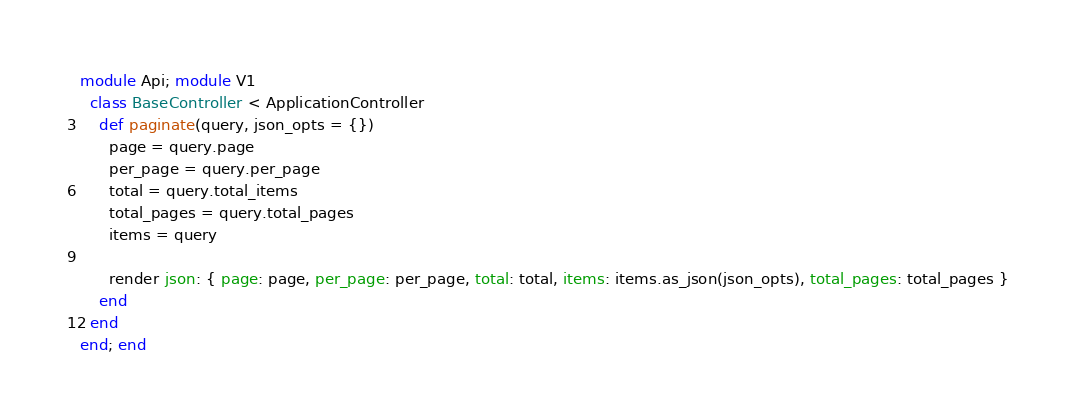<code> <loc_0><loc_0><loc_500><loc_500><_Ruby_>module Api; module V1
  class BaseController < ApplicationController
    def paginate(query, json_opts = {})
      page = query.page
      per_page = query.per_page
      total = query.total_items
      total_pages = query.total_pages
      items = query

      render json: { page: page, per_page: per_page, total: total, items: items.as_json(json_opts), total_pages: total_pages }
    end
  end
end; end
</code> 